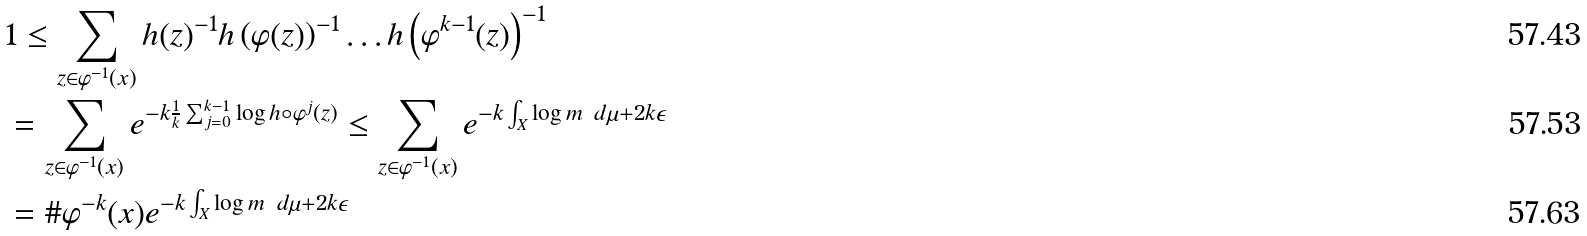<formula> <loc_0><loc_0><loc_500><loc_500>& 1 \leq \sum _ { z \in \varphi ^ { - 1 } ( x ) } h ( z ) ^ { - 1 } h \left ( \varphi ( z ) \right ) ^ { - 1 } \dots h \left ( \varphi ^ { k - 1 } ( z ) \right ) ^ { - 1 } \\ & = \sum _ { z \in \varphi ^ { - 1 } ( x ) } e ^ { - k \frac { 1 } { k } \sum _ { j = 0 } ^ { k - 1 } \log h \circ \varphi ^ { j } ( z ) } \leq \sum _ { z \in \varphi ^ { - 1 } ( x ) } e ^ { - k \int _ { X } \log m \ d \mu + 2 k \epsilon } \\ & = \# \varphi ^ { - k } ( x ) e ^ { - k \int _ { X } \log m \ d \mu + 2 k \epsilon }</formula> 